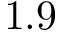<formula> <loc_0><loc_0><loc_500><loc_500>1 . 9</formula> 